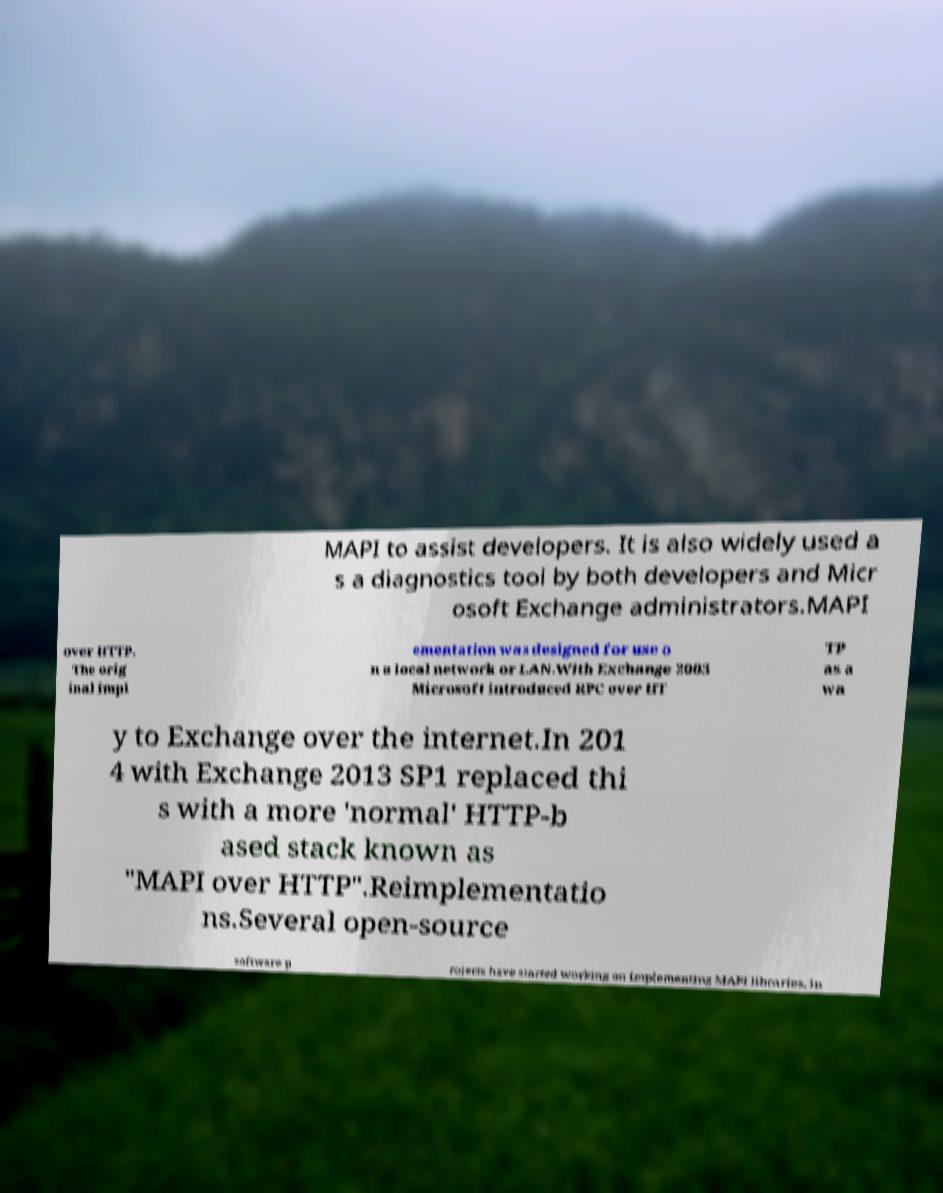Could you assist in decoding the text presented in this image and type it out clearly? MAPI to assist developers. It is also widely used a s a diagnostics tool by both developers and Micr osoft Exchange administrators.MAPI over HTTP. The orig inal impl ementation was designed for use o n a local network or LAN.With Exchange 2003 Microsoft introduced RPC over HT TP as a wa y to Exchange over the internet.In 201 4 with Exchange 2013 SP1 replaced thi s with a more 'normal' HTTP-b ased stack known as "MAPI over HTTP".Reimplementatio ns.Several open-source software p rojects have started working on implementing MAPI libraries, in 